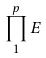<formula> <loc_0><loc_0><loc_500><loc_500>\prod _ { 1 } ^ { p } E</formula> 